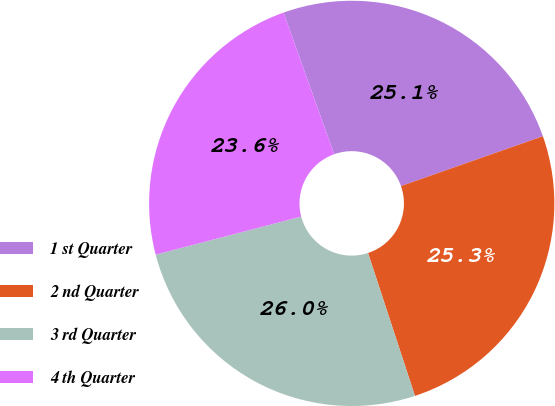Convert chart. <chart><loc_0><loc_0><loc_500><loc_500><pie_chart><fcel>1 st Quarter<fcel>2 nd Quarter<fcel>3 rd Quarter<fcel>4 th Quarter<nl><fcel>25.09%<fcel>25.33%<fcel>25.98%<fcel>23.61%<nl></chart> 